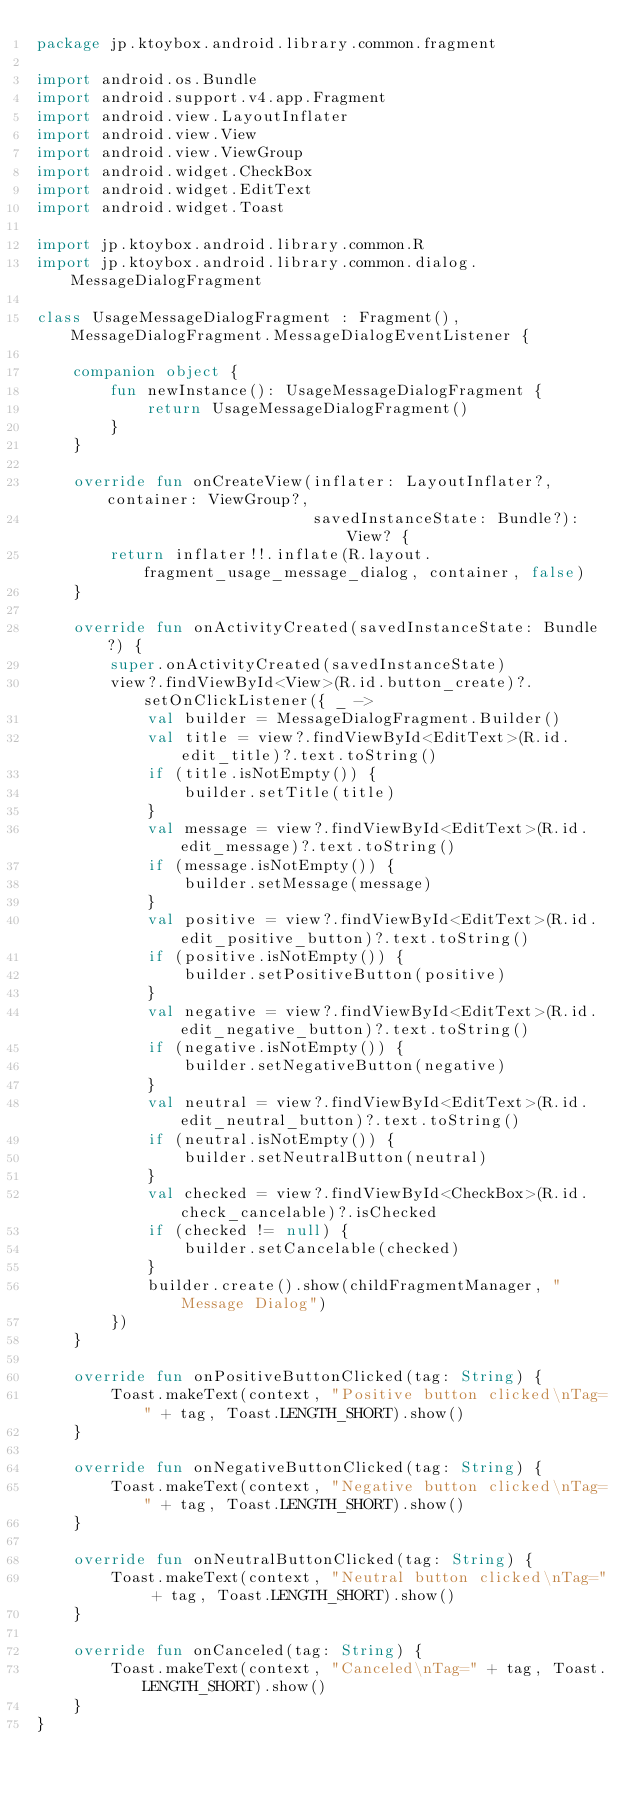<code> <loc_0><loc_0><loc_500><loc_500><_Kotlin_>package jp.ktoybox.android.library.common.fragment

import android.os.Bundle
import android.support.v4.app.Fragment
import android.view.LayoutInflater
import android.view.View
import android.view.ViewGroup
import android.widget.CheckBox
import android.widget.EditText
import android.widget.Toast

import jp.ktoybox.android.library.common.R
import jp.ktoybox.android.library.common.dialog.MessageDialogFragment

class UsageMessageDialogFragment : Fragment(), MessageDialogFragment.MessageDialogEventListener {

    companion object {
        fun newInstance(): UsageMessageDialogFragment {
            return UsageMessageDialogFragment()
        }
    }

    override fun onCreateView(inflater: LayoutInflater?, container: ViewGroup?,
                              savedInstanceState: Bundle?): View? {
        return inflater!!.inflate(R.layout.fragment_usage_message_dialog, container, false)
    }

    override fun onActivityCreated(savedInstanceState: Bundle?) {
        super.onActivityCreated(savedInstanceState)
        view?.findViewById<View>(R.id.button_create)?.setOnClickListener({ _ ->
            val builder = MessageDialogFragment.Builder()
            val title = view?.findViewById<EditText>(R.id.edit_title)?.text.toString()
            if (title.isNotEmpty()) {
                builder.setTitle(title)
            }
            val message = view?.findViewById<EditText>(R.id.edit_message)?.text.toString()
            if (message.isNotEmpty()) {
                builder.setMessage(message)
            }
            val positive = view?.findViewById<EditText>(R.id.edit_positive_button)?.text.toString()
            if (positive.isNotEmpty()) {
                builder.setPositiveButton(positive)
            }
            val negative = view?.findViewById<EditText>(R.id.edit_negative_button)?.text.toString()
            if (negative.isNotEmpty()) {
                builder.setNegativeButton(negative)
            }
            val neutral = view?.findViewById<EditText>(R.id.edit_neutral_button)?.text.toString()
            if (neutral.isNotEmpty()) {
                builder.setNeutralButton(neutral)
            }
            val checked = view?.findViewById<CheckBox>(R.id.check_cancelable)?.isChecked
            if (checked != null) {
                builder.setCancelable(checked)
            }
            builder.create().show(childFragmentManager, "Message Dialog")
        })
    }

    override fun onPositiveButtonClicked(tag: String) {
        Toast.makeText(context, "Positive button clicked\nTag=" + tag, Toast.LENGTH_SHORT).show()
    }

    override fun onNegativeButtonClicked(tag: String) {
        Toast.makeText(context, "Negative button clicked\nTag=" + tag, Toast.LENGTH_SHORT).show()
    }

    override fun onNeutralButtonClicked(tag: String) {
        Toast.makeText(context, "Neutral button clicked\nTag=" + tag, Toast.LENGTH_SHORT).show()
    }

    override fun onCanceled(tag: String) {
        Toast.makeText(context, "Canceled\nTag=" + tag, Toast.LENGTH_SHORT).show()
    }
}
</code> 